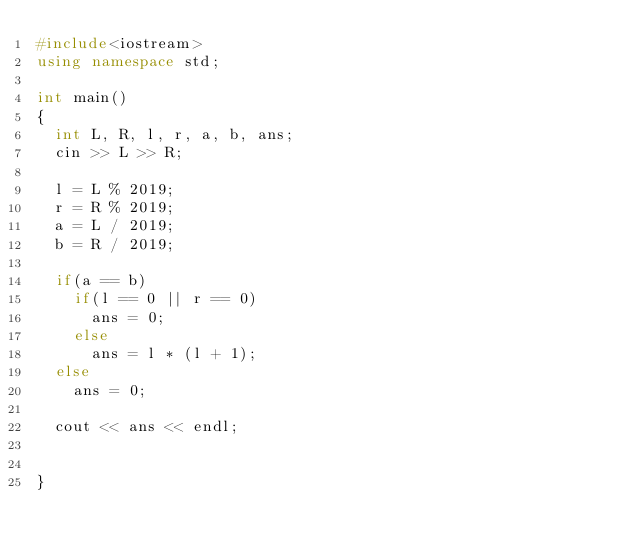Convert code to text. <code><loc_0><loc_0><loc_500><loc_500><_C++_>#include<iostream>
using namespace std;

int main()
{
  int L, R, l, r, a, b, ans;
  cin >> L >> R;

  l = L % 2019;
  r = R % 2019;
  a = L / 2019;
  b = R / 2019;

  if(a == b)
    if(l == 0 || r == 0)
      ans = 0;
    else
      ans = l * (l + 1);
  else
    ans = 0;

  cout << ans << endl;


}
</code> 